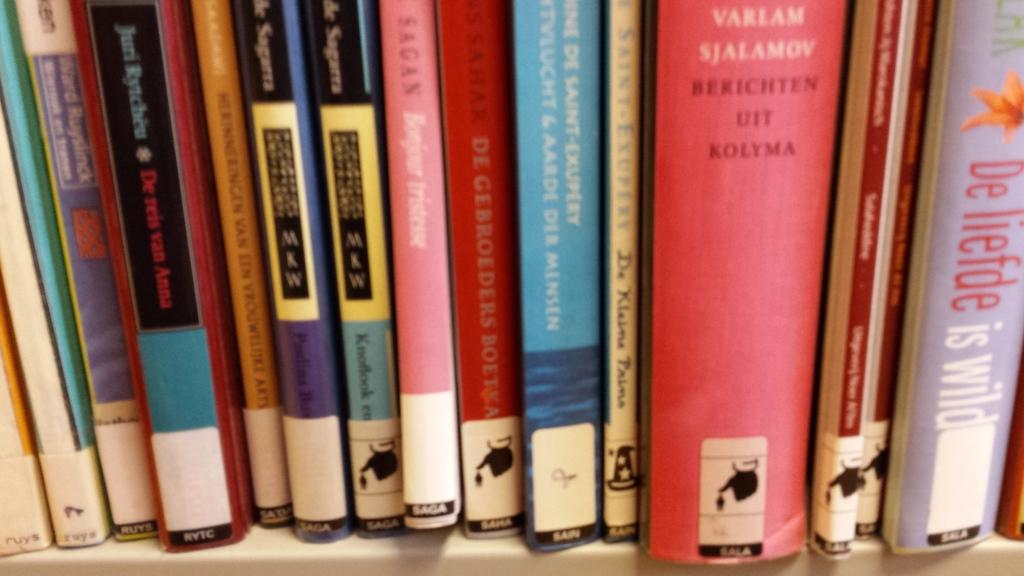Provide a one-sentence caption for the provided image. Various books with labels near the bottom denoting SAGA, SALA, RVTC etc. 